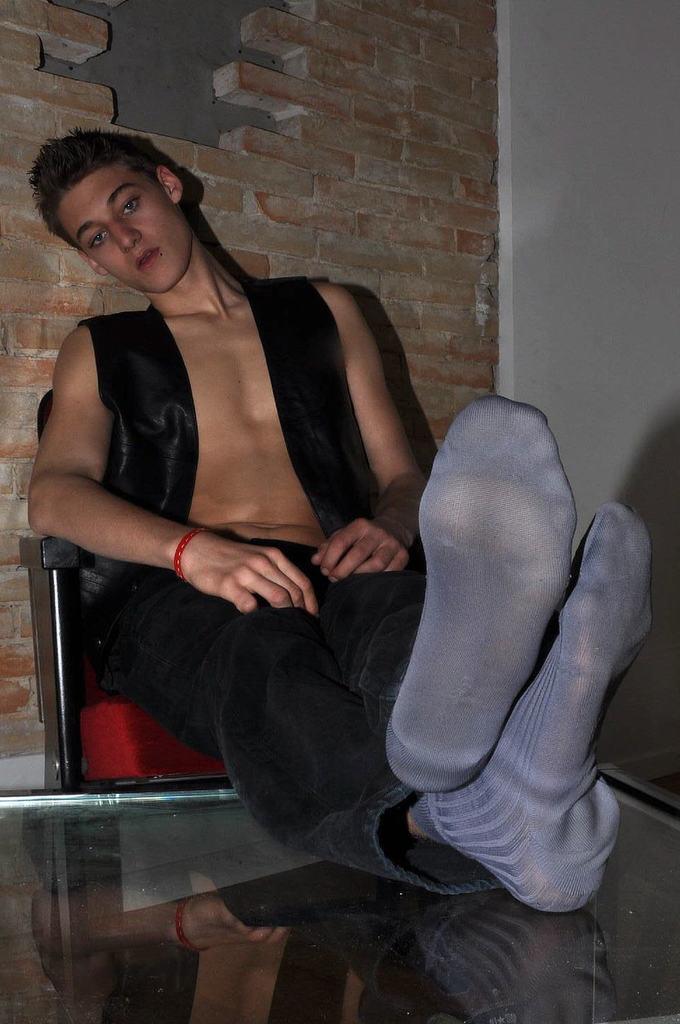Could you give a brief overview of what you see in this image? In this image in the center there is one person sitting on a chair, and in front of him there is a table like object and in the background there is wall. 